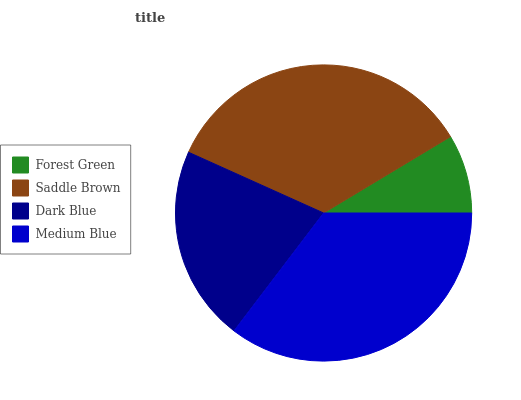Is Forest Green the minimum?
Answer yes or no. Yes. Is Medium Blue the maximum?
Answer yes or no. Yes. Is Saddle Brown the minimum?
Answer yes or no. No. Is Saddle Brown the maximum?
Answer yes or no. No. Is Saddle Brown greater than Forest Green?
Answer yes or no. Yes. Is Forest Green less than Saddle Brown?
Answer yes or no. Yes. Is Forest Green greater than Saddle Brown?
Answer yes or no. No. Is Saddle Brown less than Forest Green?
Answer yes or no. No. Is Saddle Brown the high median?
Answer yes or no. Yes. Is Dark Blue the low median?
Answer yes or no. Yes. Is Dark Blue the high median?
Answer yes or no. No. Is Saddle Brown the low median?
Answer yes or no. No. 